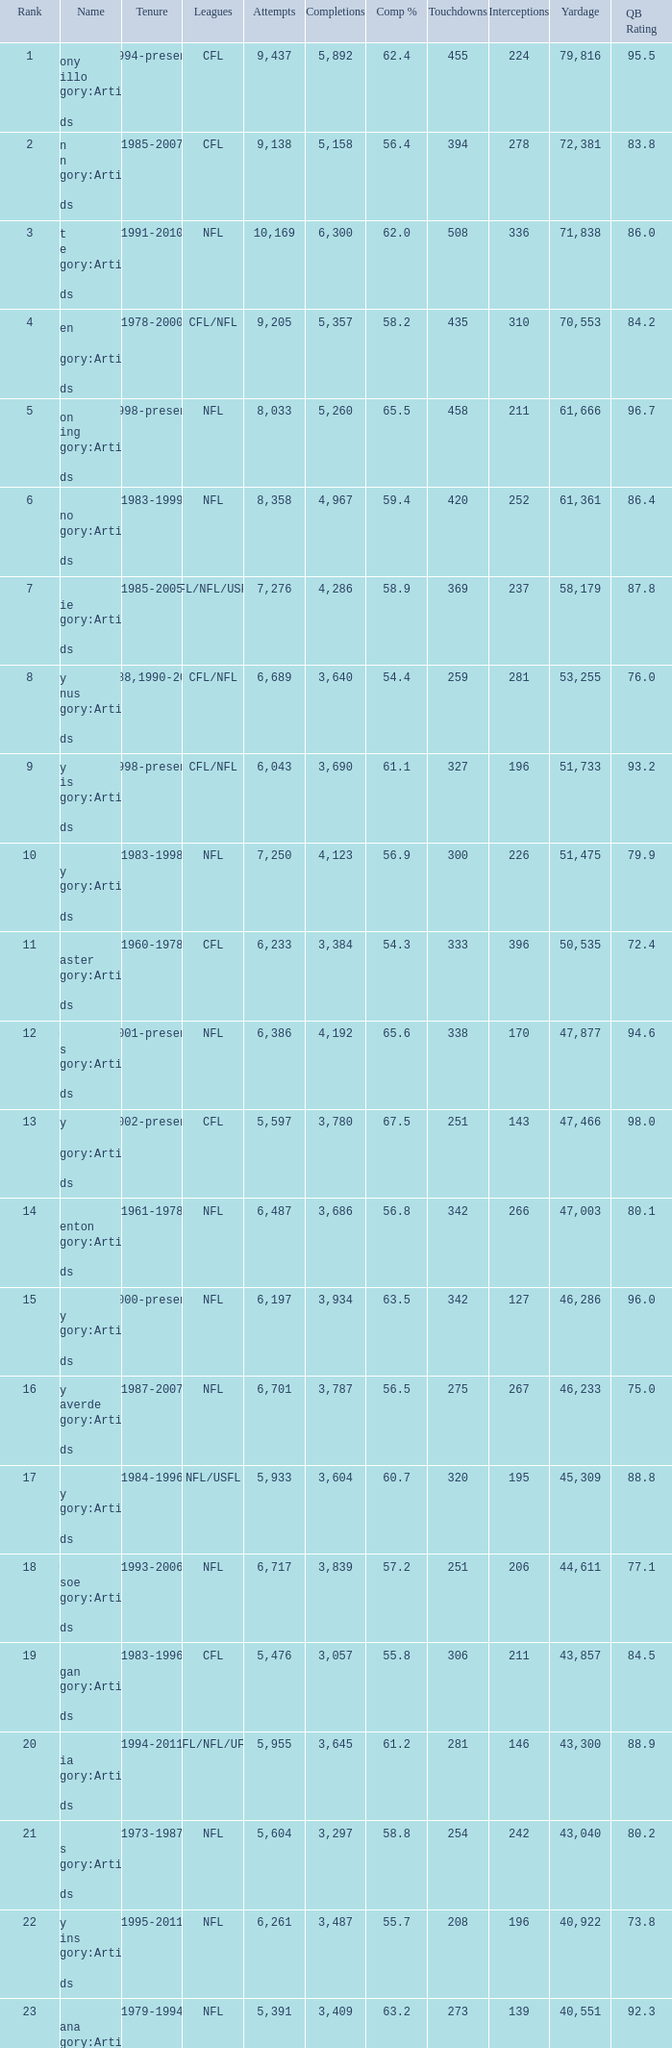What is the number of interceptions with less than 3,487 completions , more than 40,551 yardage, and the comp % is 55.8? 211.0. 